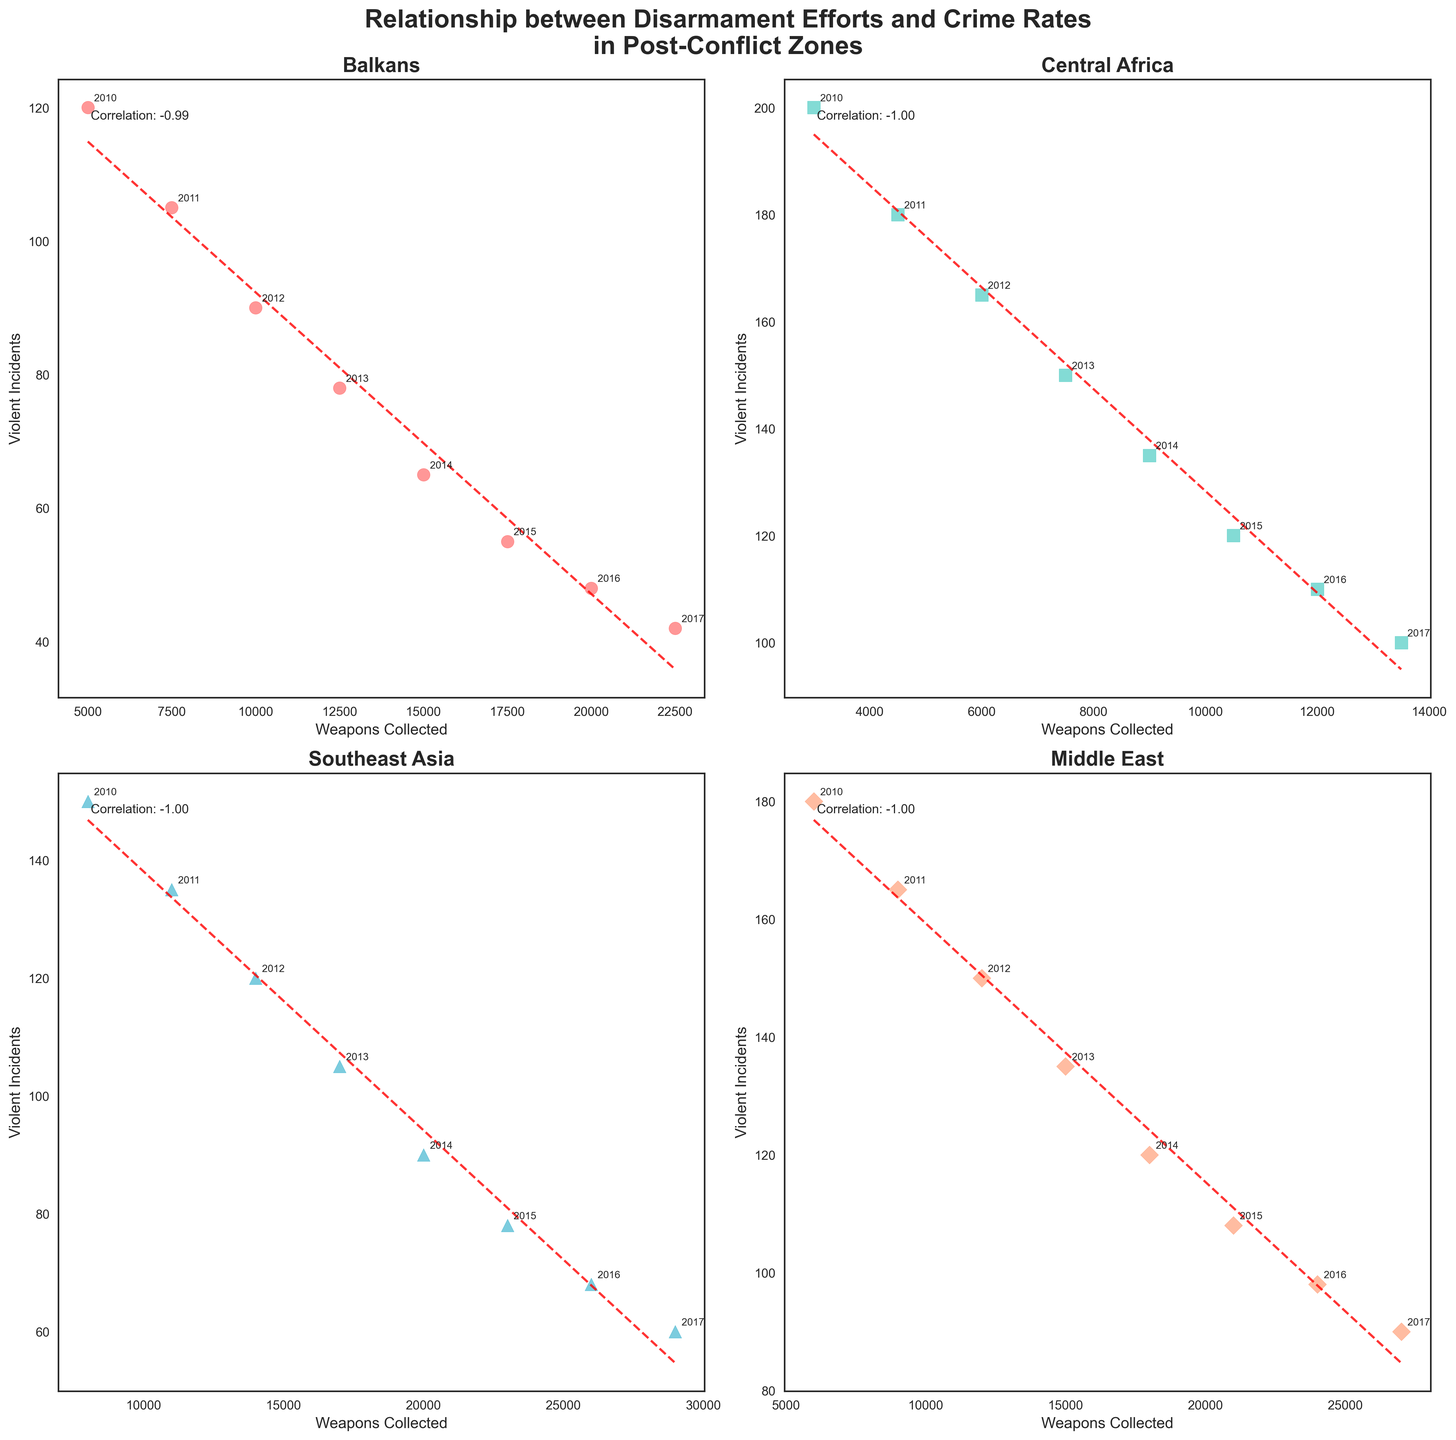Which region shows the highest correlation between weapons collected and violent incidents? Look at the correlation coefficients noted in each subplot. The region with the highest positive correlation coefficient indicates the strongest linear association, regardless of the direction of the relationship.
Answer: Balkans Which region's trendline shows the steepest decline in violent incidents as weapons collected increase? Observe the slope of the trendlines in each subplot. The subplot with the trendline that has the steepest negative slope indicates the region with the steepest decline in violent incidents.
Answer: Southeast Asia Compare the initial (2010) and final (2017) violent incident values for Central Africa. How many incidents decreased? For Central Africa, note the values for 2010 and 2017. Subtract the number of incidents in 2017 from those in 2010 to find the decrease.
Answer: 100 Which region sees the least reduction in violent incidents from 2013 to 2014? Check the year labels and compare the values between 2013 and 2014 on the y-axis for each subplot. The one with the smallest change in violent incidents between these two years is the region with the least reduction.
Answer: Central Africa In 2012, which region had the highest number of violent incidents reported? Look at the data points for the year 2012 in each subplot and compare the y-values (violent incidents). The highest point represents the region with the most incidents.
Answer: Central Africa Calculate the total number of violent incidents reported across all regions in 2015. Identify the 2015 points in each subplot and sum their y-values (violent incidents): Balkans, Central Africa, Southeast Asia, and Middle East.
Answer: 361 What can you infer about the effectiveness of disarmament efforts in the Balkans based on the trendline? The downward sloping trendline in the Balkans subplot indicates that as more weapons are collected, the number of violent incidents tends to decrease, suggesting effective disarmament efforts.
Answer: Effective Which region collected the most weapons by 2017? Compare the x-values (weapons collected) for the year 2017 across all subplots. The highest x-value corresponds to the region that collected the most weapons.
Answer: Southeast Asia 